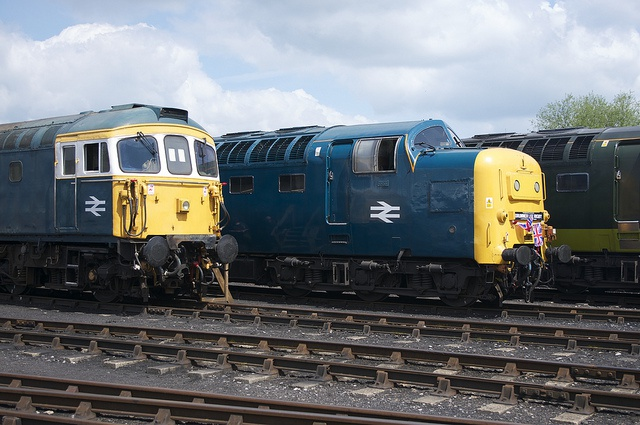Describe the objects in this image and their specific colors. I can see train in lightblue, black, darkblue, blue, and khaki tones, train in lightblue, black, darkblue, gray, and darkgray tones, and train in lightblue, black, gray, purple, and darkgray tones in this image. 